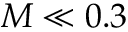<formula> <loc_0><loc_0><loc_500><loc_500>M \ll 0 . 3</formula> 